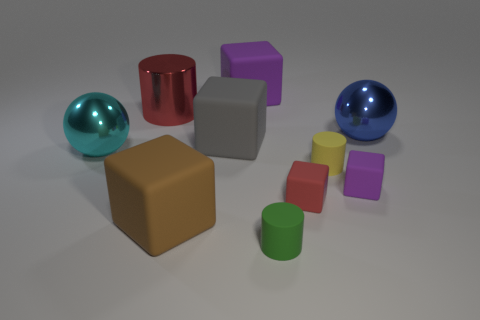How many objects are blue things or large shiny cylinders?
Ensure brevity in your answer.  2. Are the large sphere that is on the left side of the blue metal thing and the purple thing that is in front of the tiny yellow rubber cylinder made of the same material?
Offer a very short reply. No. What is the color of the other ball that is the same material as the big cyan ball?
Ensure brevity in your answer.  Blue. How many red metallic cylinders have the same size as the yellow rubber cylinder?
Keep it short and to the point. 0. How many other things are the same color as the large metal cylinder?
Ensure brevity in your answer.  1. Is there any other thing that is the same size as the red metallic cylinder?
Provide a succinct answer. Yes. Do the thing behind the big red metallic cylinder and the small matte thing that is behind the tiny purple thing have the same shape?
Provide a succinct answer. No. There is a red thing that is the same size as the cyan ball; what shape is it?
Your answer should be compact. Cylinder. Is the number of large cylinders that are in front of the brown thing the same as the number of large cyan metallic balls in front of the large metal cylinder?
Your response must be concise. No. Is there any other thing that is the same shape as the small purple object?
Make the answer very short. Yes. 